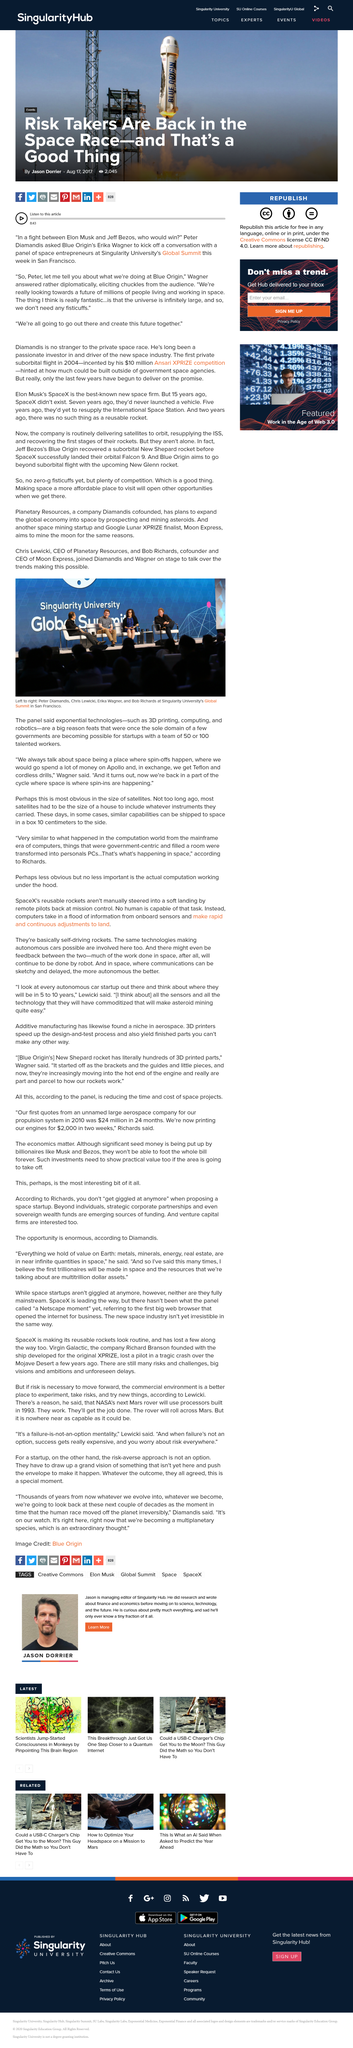Identify some key points in this picture. Planeth The Singularity University's global summit was held in San Francisco. Exponential technologies such as 3D printing, computing, and robotics are making it possible for startups to achieve unprecedented levels of innovation and progress. 